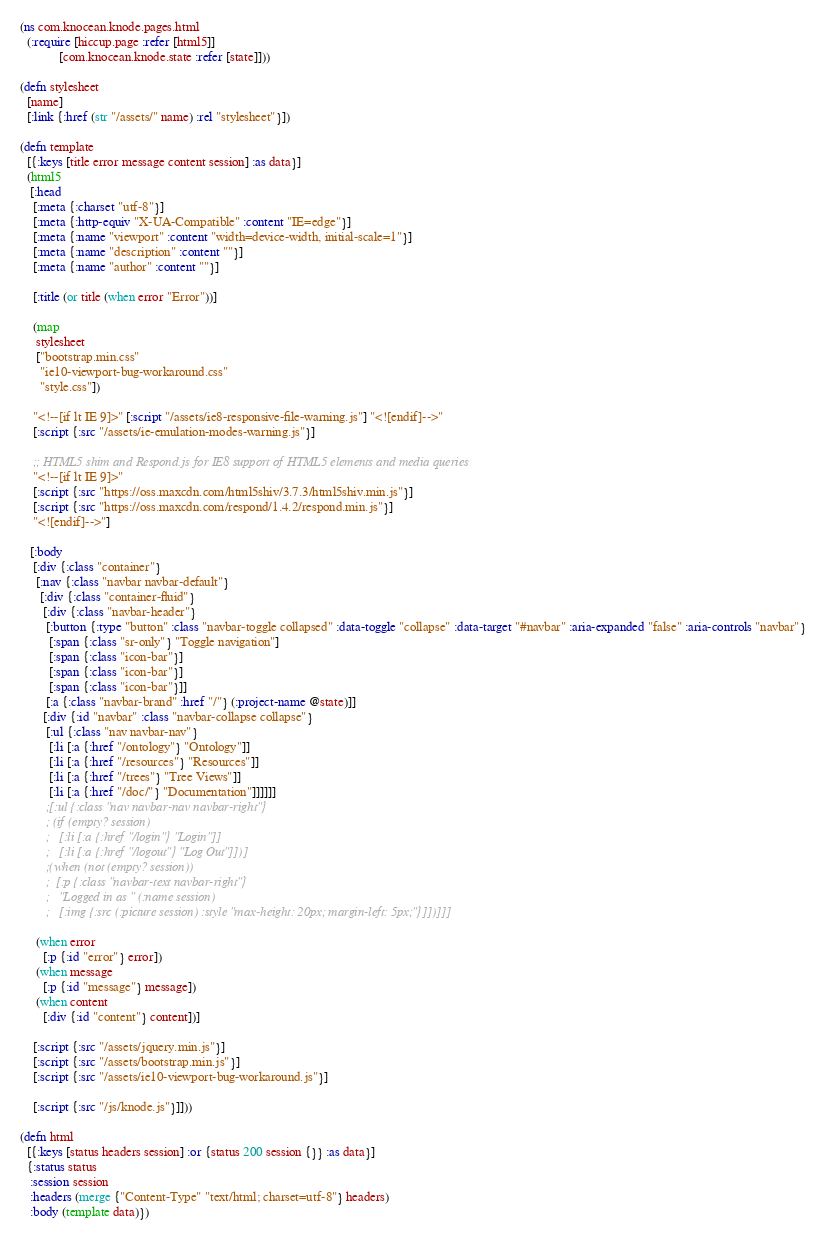Convert code to text. <code><loc_0><loc_0><loc_500><loc_500><_Clojure_>(ns com.knocean.knode.pages.html
  (:require [hiccup.page :refer [html5]]
            [com.knocean.knode.state :refer [state]]))

(defn stylesheet
  [name]
  [:link {:href (str "/assets/" name) :rel "stylesheet"}])

(defn template
  [{:keys [title error message content session] :as data}]
  (html5
   [:head
    [:meta {:charset "utf-8"}]
    [:meta {:http-equiv "X-UA-Compatible" :content "IE=edge"}]
    [:meta {:name "viewport" :content "width=device-width, initial-scale=1"}]
    [:meta {:name "description" :content ""}]
    [:meta {:name "author" :content ""}]

    [:title (or title (when error "Error"))]

    (map
     stylesheet
     ["bootstrap.min.css"
      "ie10-viewport-bug-workaround.css"
      "style.css"])

    "<!--[if lt IE 9]>" [:script "/assets/ie8-responsive-file-warning.js"] "<![endif]-->"
    [:script {:src "/assets/ie-emulation-modes-warning.js"}]

    ;; HTML5 shim and Respond.js for IE8 support of HTML5 elements and media queries
    "<!--[if lt IE 9]>"
    [:script {:src "https://oss.maxcdn.com/html5shiv/3.7.3/html5shiv.min.js"}]
    [:script {:src "https://oss.maxcdn.com/respond/1.4.2/respond.min.js"}]
    "<![endif]-->"]

   [:body
    [:div {:class "container"}
     [:nav {:class "navbar navbar-default"}
      [:div {:class "container-fluid"}
       [:div {:class "navbar-header"}
        [:button {:type "button" :class "navbar-toggle collapsed" :data-toggle "collapse" :data-target "#navbar" :aria-expanded "false" :aria-controls "navbar"}
         [:span {:class "sr-only"} "Toggle navigation"]
         [:span {:class "icon-bar"}]
         [:span {:class "icon-bar"}]
         [:span {:class "icon-bar"}]]
        [:a {:class "navbar-brand" :href "/"} (:project-name @state)]]
       [:div {:id "navbar" :class "navbar-collapse collapse"}
        [:ul {:class "nav navbar-nav"}
         [:li [:a {:href "/ontology"} "Ontology"]]
         [:li [:a {:href "/resources"} "Resources"]]
         [:li [:a {:href "/trees"} "Tree Views"]]
         [:li [:a {:href "/doc/"} "Documentation"]]]]]]
        ;[:ul {:class "nav navbar-nav navbar-right"}
        ; (if (empty? session)
        ;   [:li [:a {:href "/login"} "Login"]]
        ;   [:li [:a {:href "/logout"} "Log Out"]])]
        ;(when (not (empty? session))
        ;  [:p {:class "navbar-text navbar-right"}
        ;   "Logged in as " (:name session)
        ;   [:img {:src (:picture session) :style "max-height: 20px; margin-left: 5px;"}]])]]]

     (when error
       [:p {:id "error"} error])
     (when message
       [:p {:id "message"} message])
     (when content
       [:div {:id "content"} content])]

    [:script {:src "/assets/jquery.min.js"}]
    [:script {:src "/assets/bootstrap.min.js"}]
    [:script {:src "/assets/ie10-viewport-bug-workaround.js"}]

    [:script {:src "/js/knode.js"}]]))

(defn html
  [{:keys [status headers session] :or {status 200 session {}} :as data}]
  {:status status
   :session session
   :headers (merge {"Content-Type" "text/html; charset=utf-8"} headers)
   :body (template data)})
</code> 